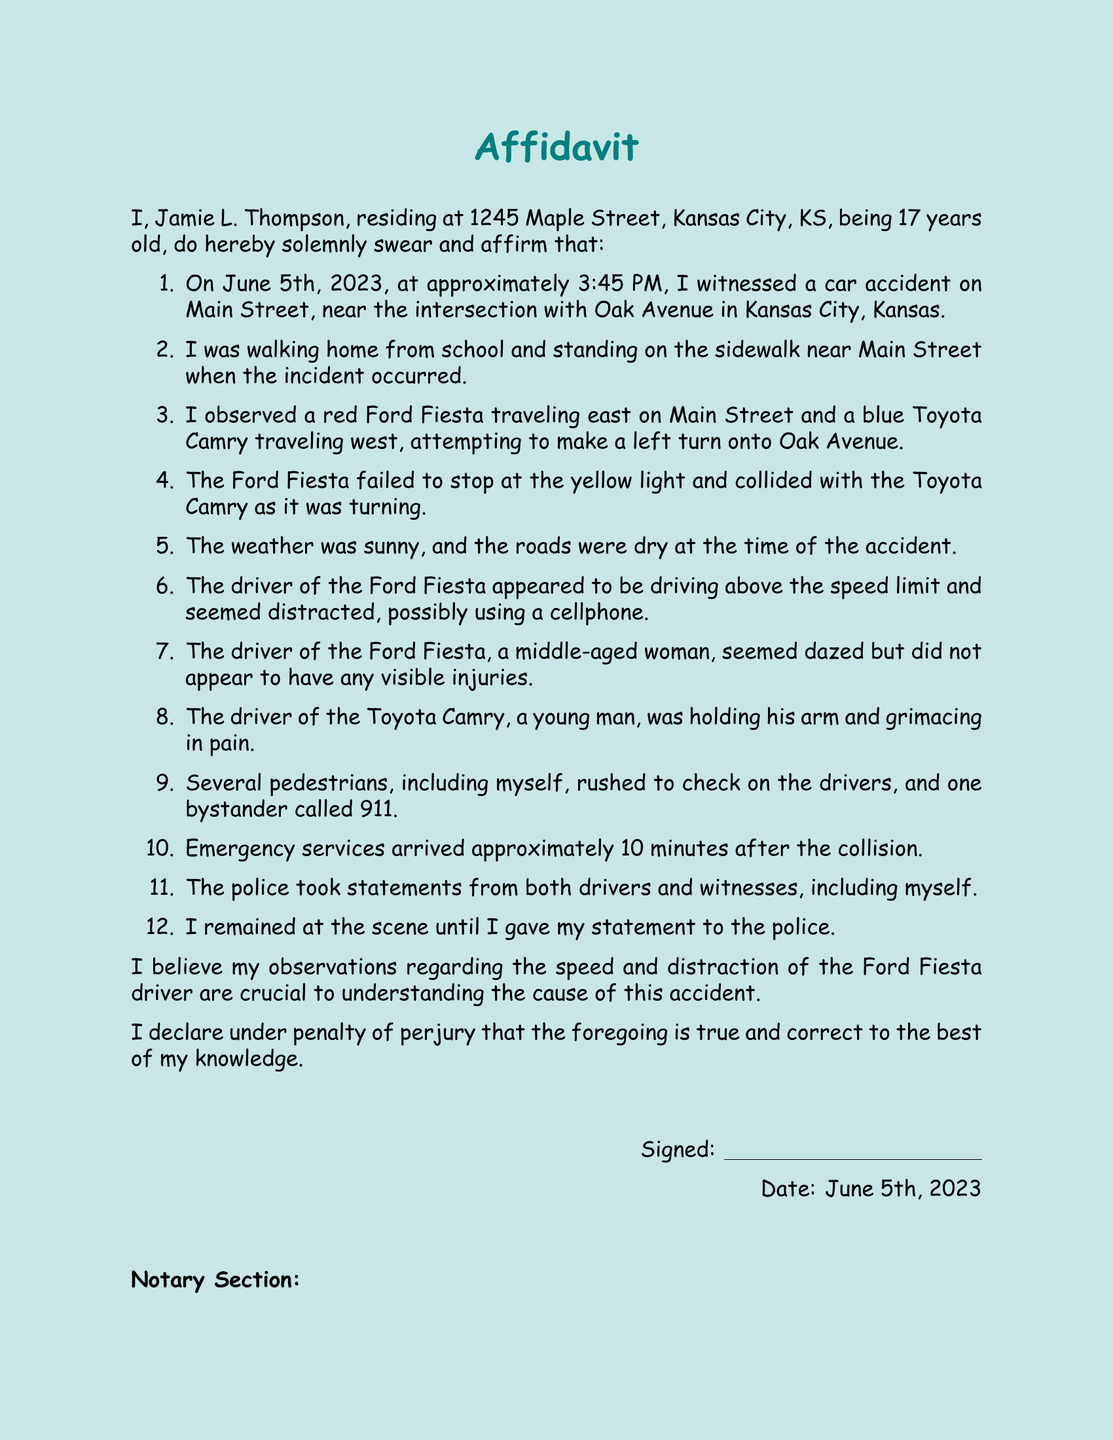What is the witness's name? The witness is identified as Jamie L. Thompson in the affidavit.
Answer: Jamie L. Thompson What is the date of the accident? The affidavit specifies that the accident occurred on June 5th, 2023.
Answer: June 5th, 2023 What color was the Ford Fiesta? According to the witness statement, the Ford Fiesta was red.
Answer: red Where were the vehicles involved in the accident traveling? The affidavit states the Ford Fiesta was traveling east and the Toyota Camry was traveling west.
Answer: east; west What was the weather like at the time of the accident? The witness notes that the weather was sunny when the accident happened.
Answer: sunny How long did it take for emergency services to arrive? The affidavit indicates that emergency services arrived approximately 10 minutes after the collision.
Answer: 10 minutes What was the condition of the driver of the Toyota Camry? The witness observed that the driver was holding his arm and grimacing in pain.
Answer: holding his arm, grimacing in pain What does the affidavit declare under penalty of? The affidavit specifies that it is declared under penalty of perjury.
Answer: perjury What is the document type? The title at the beginning indicates that this is an affidavit.
Answer: affidavit 